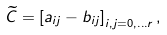<formula> <loc_0><loc_0><loc_500><loc_500>\widetilde { C } = \left [ a _ { i j } - b _ { i j } \right ] _ { i , j = 0 , \dots r } ,</formula> 